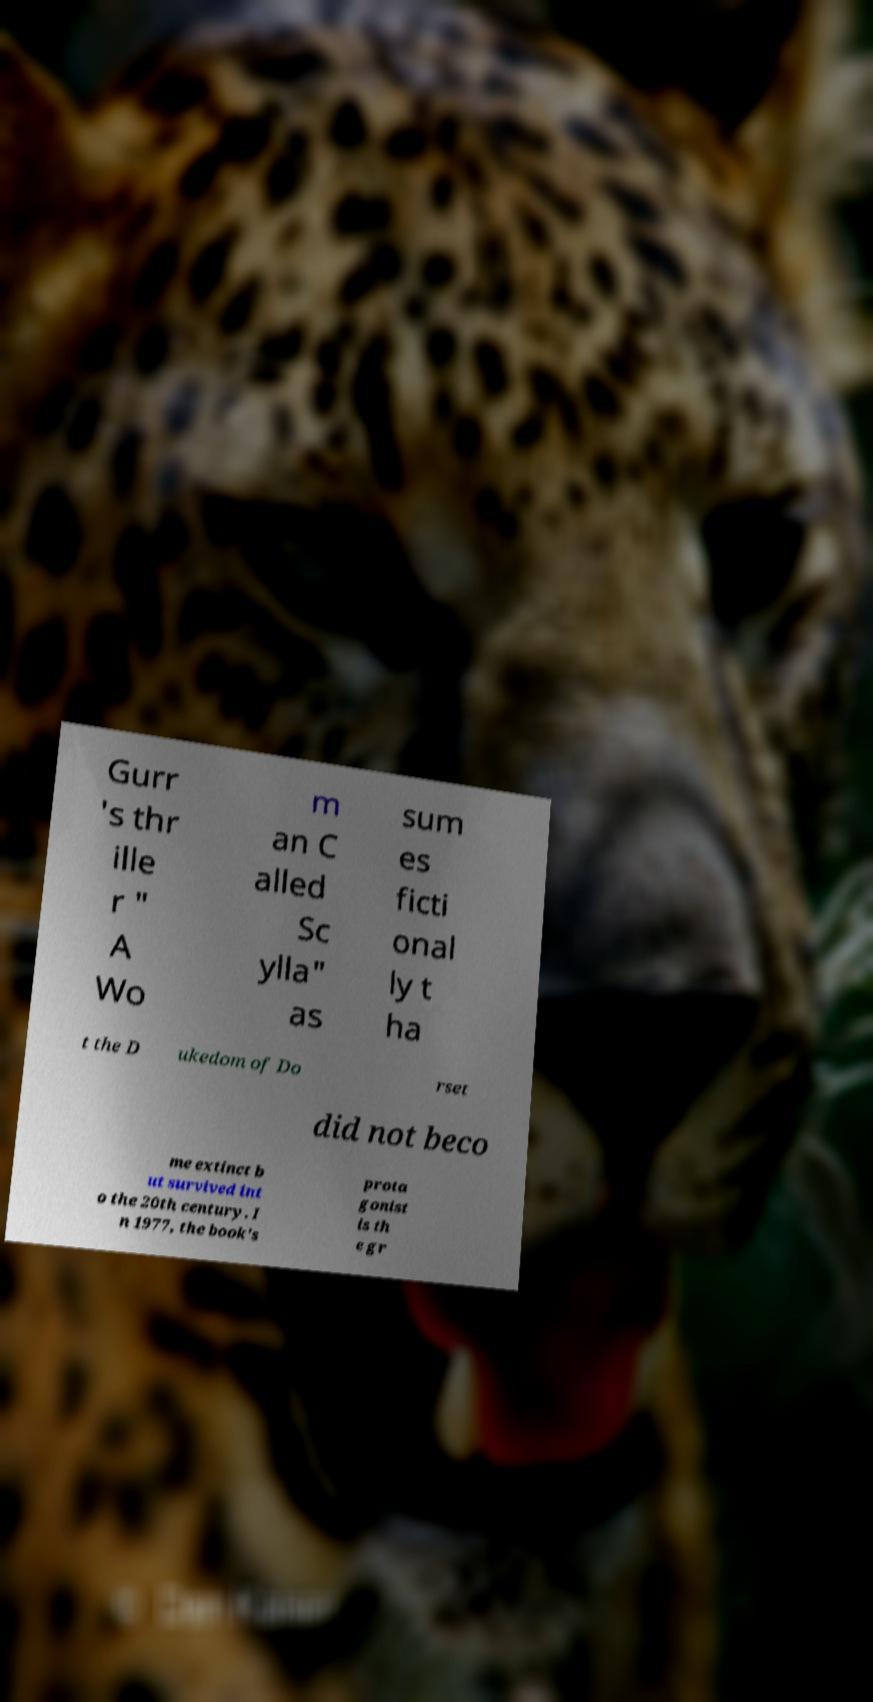Could you extract and type out the text from this image? Gurr 's thr ille r " A Wo m an C alled Sc ylla" as sum es ficti onal ly t ha t the D ukedom of Do rset did not beco me extinct b ut survived int o the 20th century. I n 1977, the book's prota gonist is th e gr 